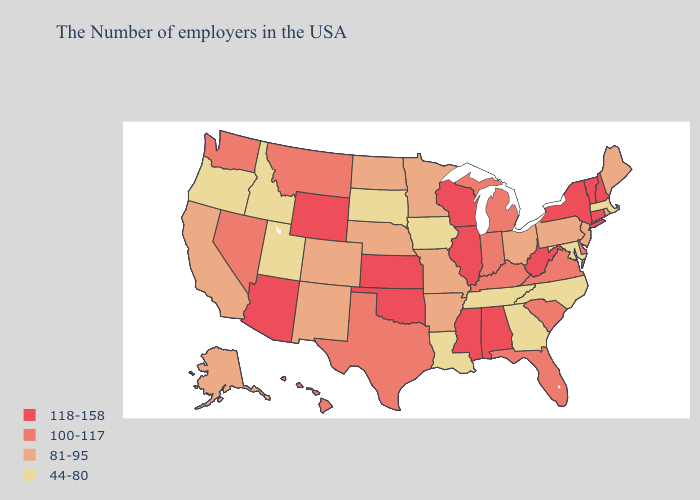What is the highest value in states that border New Mexico?
Be succinct. 118-158. Which states have the lowest value in the South?
Be succinct. Maryland, North Carolina, Georgia, Tennessee, Louisiana. Name the states that have a value in the range 118-158?
Concise answer only. New Hampshire, Vermont, Connecticut, New York, West Virginia, Alabama, Wisconsin, Illinois, Mississippi, Kansas, Oklahoma, Wyoming, Arizona. Does Maryland have a lower value than South Carolina?
Answer briefly. Yes. Name the states that have a value in the range 118-158?
Short answer required. New Hampshire, Vermont, Connecticut, New York, West Virginia, Alabama, Wisconsin, Illinois, Mississippi, Kansas, Oklahoma, Wyoming, Arizona. How many symbols are there in the legend?
Short answer required. 4. Does New Jersey have the highest value in the Northeast?
Write a very short answer. No. Name the states that have a value in the range 118-158?
Short answer required. New Hampshire, Vermont, Connecticut, New York, West Virginia, Alabama, Wisconsin, Illinois, Mississippi, Kansas, Oklahoma, Wyoming, Arizona. Name the states that have a value in the range 81-95?
Quick response, please. Maine, Rhode Island, New Jersey, Pennsylvania, Ohio, Missouri, Arkansas, Minnesota, Nebraska, North Dakota, Colorado, New Mexico, California, Alaska. What is the value of Hawaii?
Keep it brief. 100-117. Name the states that have a value in the range 118-158?
Concise answer only. New Hampshire, Vermont, Connecticut, New York, West Virginia, Alabama, Wisconsin, Illinois, Mississippi, Kansas, Oklahoma, Wyoming, Arizona. What is the value of Delaware?
Quick response, please. 100-117. What is the highest value in states that border West Virginia?
Write a very short answer. 100-117. What is the lowest value in the West?
Short answer required. 44-80. Among the states that border Nevada , does Oregon have the lowest value?
Short answer required. Yes. 